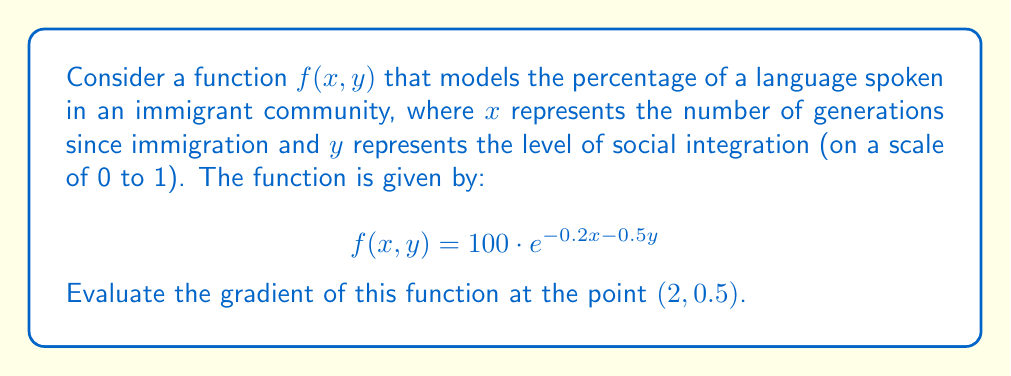Solve this math problem. To find the gradient of the function $f(x, y) = 100 \cdot e^{-0.2x - 0.5y}$, we need to calculate its partial derivatives with respect to $x$ and $y$.

Step 1: Calculate $\frac{\partial f}{\partial x}$
$$\frac{\partial f}{\partial x} = 100 \cdot (-0.2) \cdot e^{-0.2x - 0.5y} = -20 \cdot e^{-0.2x - 0.5y}$$

Step 2: Calculate $\frac{\partial f}{\partial y}$
$$\frac{\partial f}{\partial y} = 100 \cdot (-0.5) \cdot e^{-0.2x - 0.5y} = -50 \cdot e^{-0.2x - 0.5y}$$

Step 3: The gradient is defined as:
$$\nabla f(x, y) = \left(\frac{\partial f}{\partial x}, \frac{\partial f}{\partial y}\right) = (-20 \cdot e^{-0.2x - 0.5y}, -50 \cdot e^{-0.2x - 0.5y})$$

Step 4: Evaluate the gradient at the point $(2, 0.5)$
$$\nabla f(2, 0.5) = (-20 \cdot e^{-0.2(2) - 0.5(0.5)}, -50 \cdot e^{-0.2(2) - 0.5(0.5)})$$
$$= (-20 \cdot e^{-0.65}, -50 \cdot e^{-0.65})$$
$$\approx (-10.45, -26.13)$$

This gradient vector indicates the direction of steepest increase in the language shift function at the given point, and its magnitude represents the rate of change in that direction.
Answer: $(-10.45, -26.13)$ 